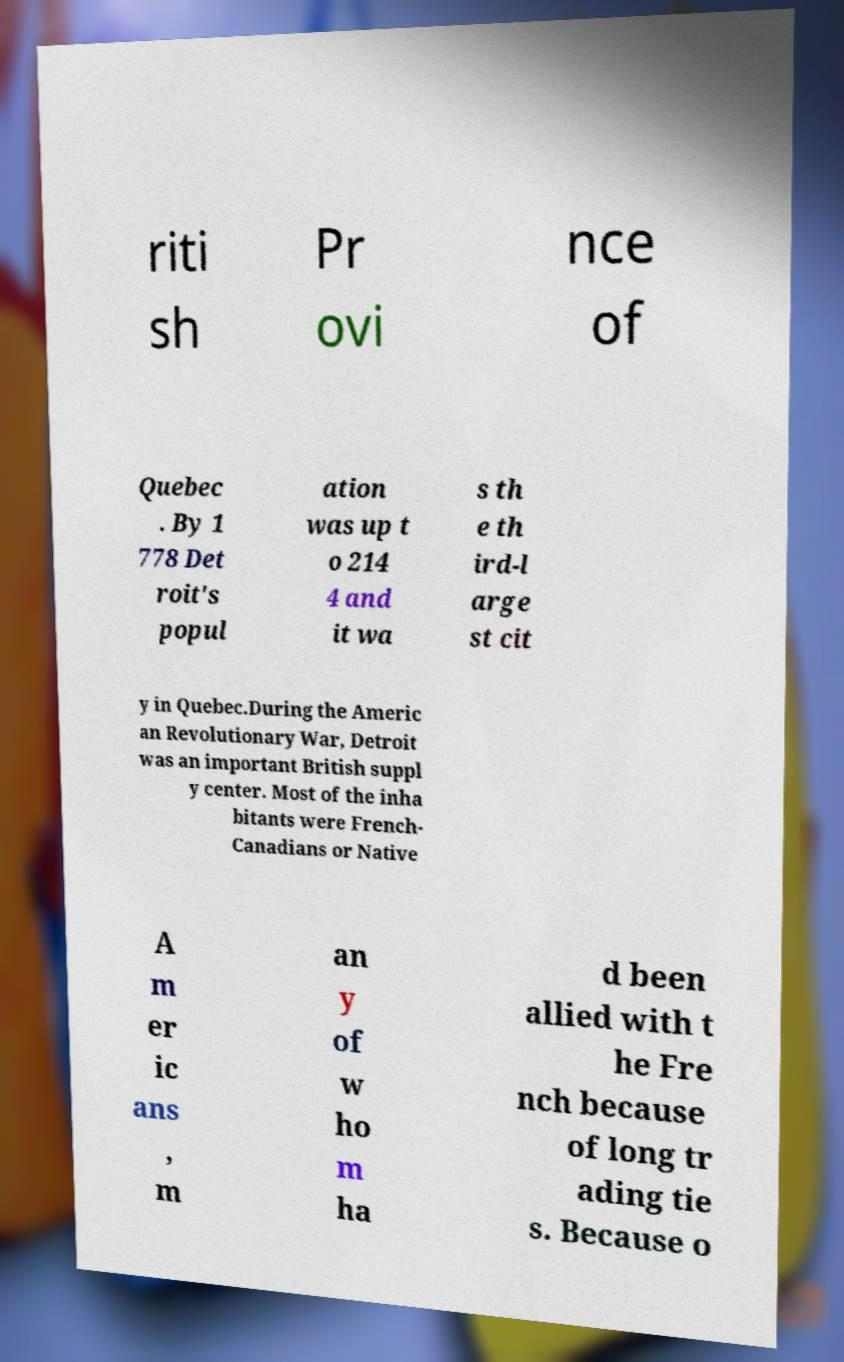What messages or text are displayed in this image? I need them in a readable, typed format. riti sh Pr ovi nce of Quebec . By 1 778 Det roit's popul ation was up t o 214 4 and it wa s th e th ird-l arge st cit y in Quebec.During the Americ an Revolutionary War, Detroit was an important British suppl y center. Most of the inha bitants were French- Canadians or Native A m er ic ans , m an y of w ho m ha d been allied with t he Fre nch because of long tr ading tie s. Because o 